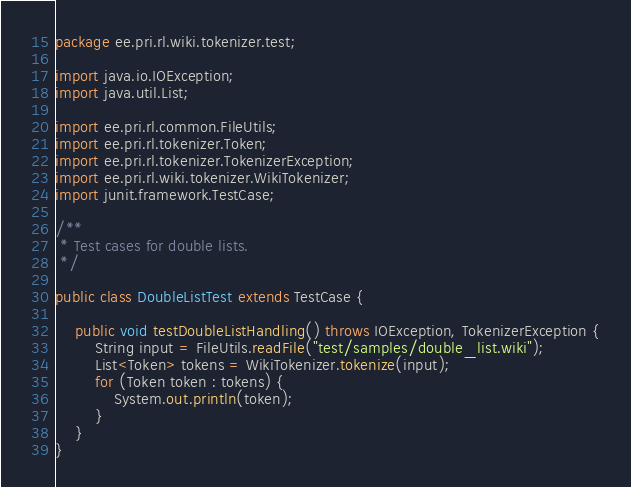Convert code to text. <code><loc_0><loc_0><loc_500><loc_500><_Java_>package ee.pri.rl.wiki.tokenizer.test;

import java.io.IOException;
import java.util.List;

import ee.pri.rl.common.FileUtils;
import ee.pri.rl.tokenizer.Token;
import ee.pri.rl.tokenizer.TokenizerException;
import ee.pri.rl.wiki.tokenizer.WikiTokenizer;
import junit.framework.TestCase;

/**
 * Test cases for double lists.
 */

public class DoubleListTest extends TestCase {

	public void testDoubleListHandling() throws IOException, TokenizerException {
		String input = FileUtils.readFile("test/samples/double_list.wiki");
		List<Token> tokens = WikiTokenizer.tokenize(input);
		for (Token token : tokens) {
			System.out.println(token);
		}
	}
}
</code> 